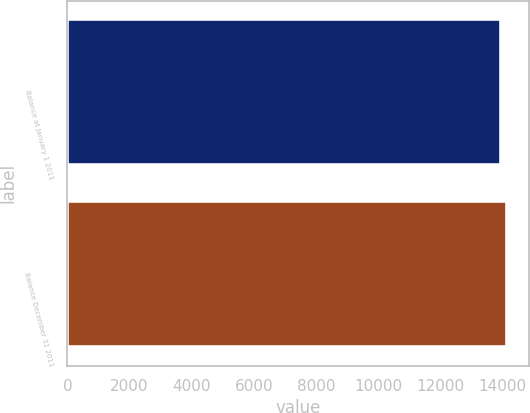Convert chart to OTSL. <chart><loc_0><loc_0><loc_500><loc_500><bar_chart><fcel>Balance at January 1 2011<fcel>Balance December 31 2011<nl><fcel>13952<fcel>14154<nl></chart> 